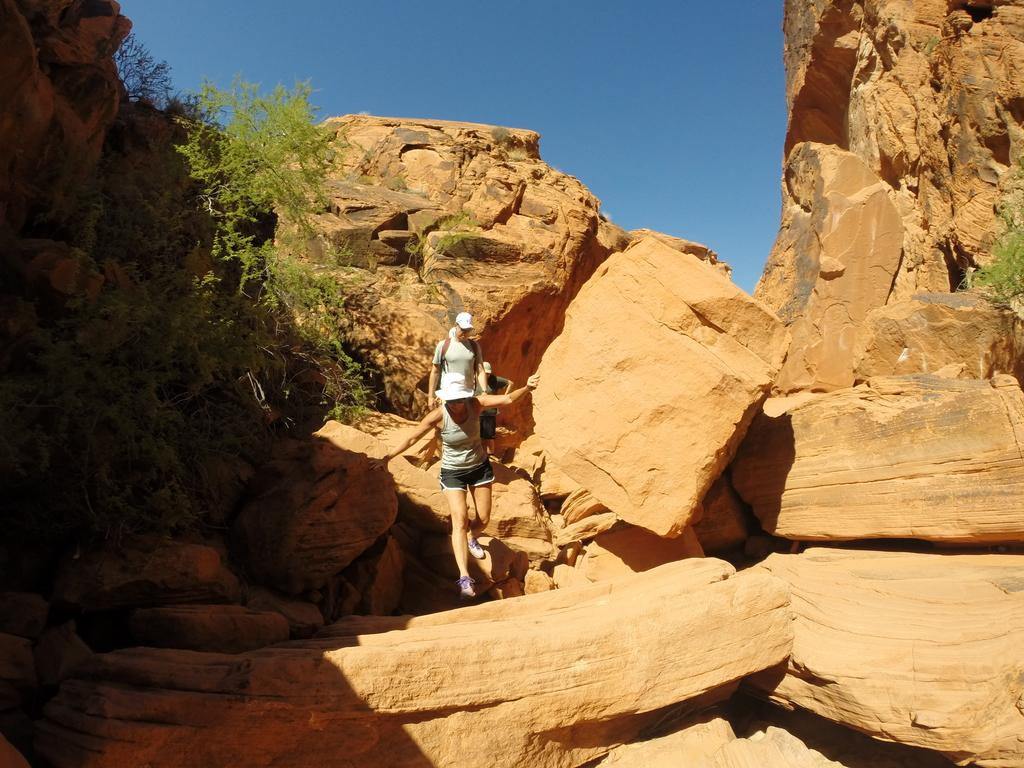Who or what can be seen in the image? There are persons in the image. What type of natural elements are present in the image? There are rocks and trees in the image. What can be seen in the background of the image? The sky is visible in the background of the image. What type of ear is visible on the person in the image? There is no ear visible on a person in the image; only the persons, rocks, trees, and sky are present. 